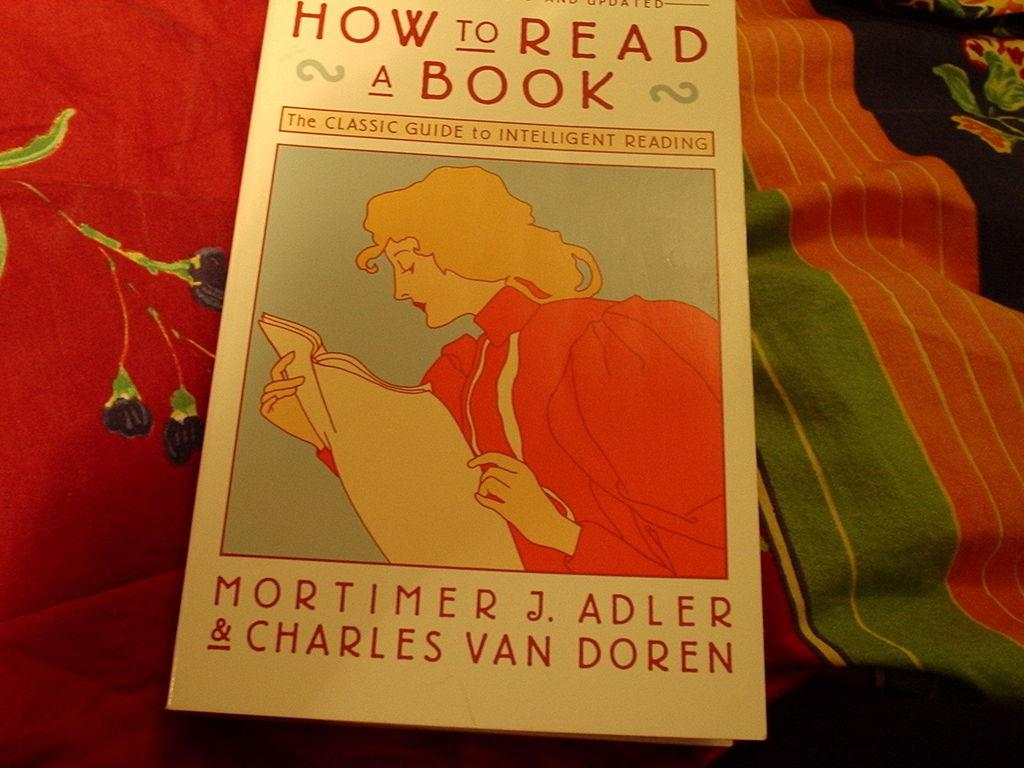<image>
Write a terse but informative summary of the picture. A book called "How to Read a Book." 